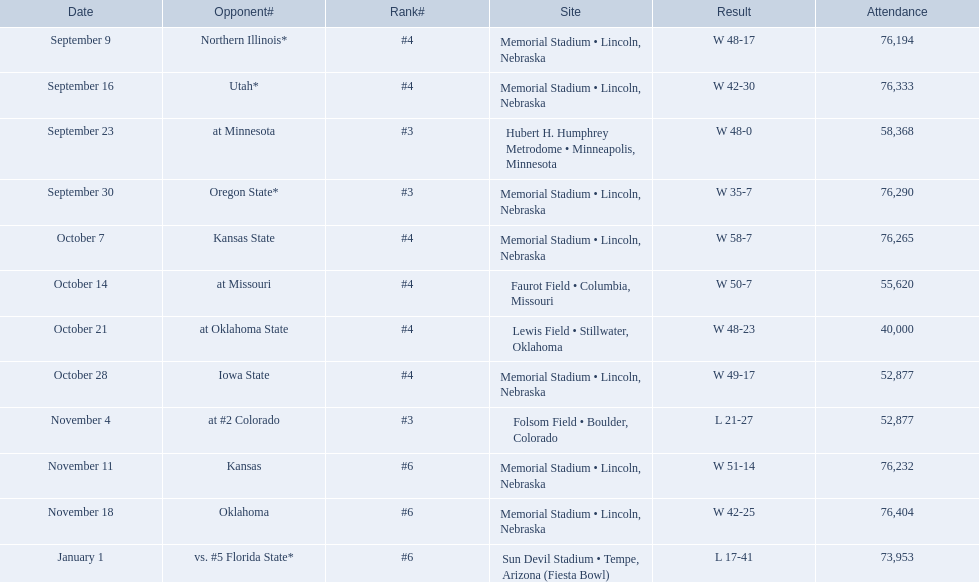How many games was their ranking not lower than #5? 9. 